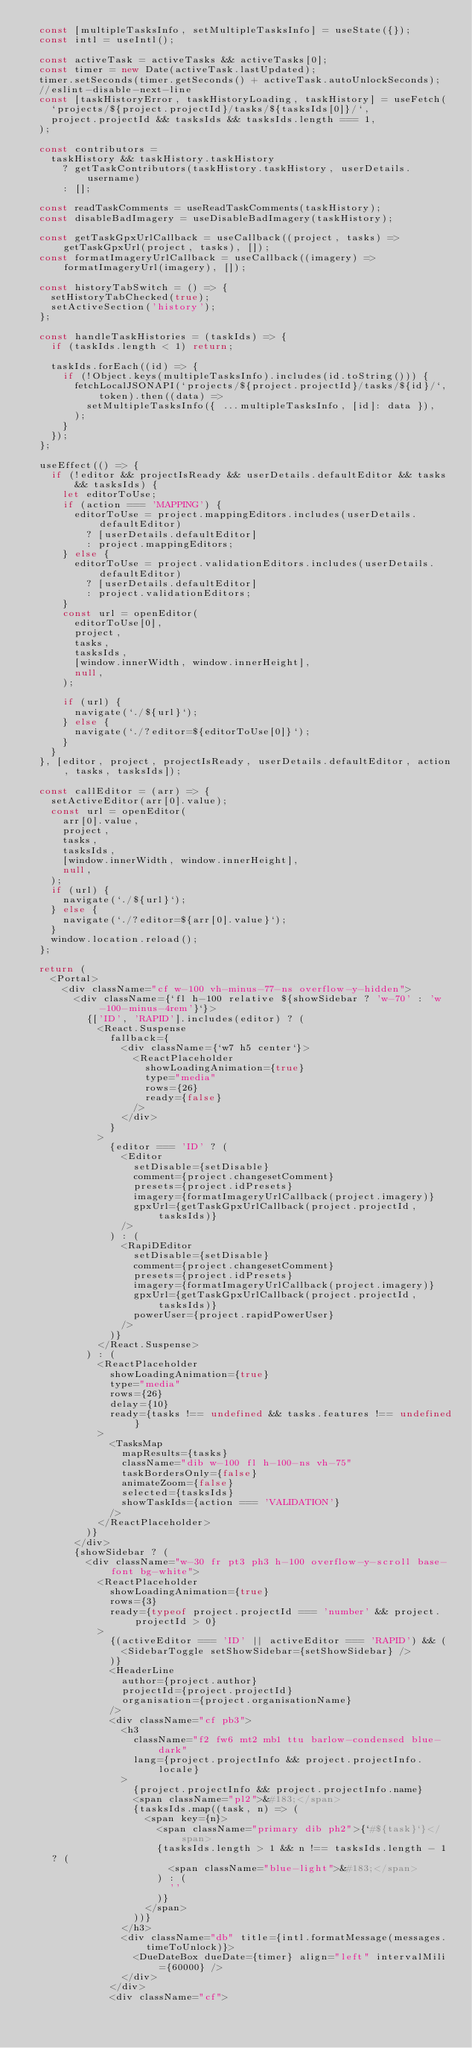Convert code to text. <code><loc_0><loc_0><loc_500><loc_500><_JavaScript_>  const [multipleTasksInfo, setMultipleTasksInfo] = useState({});
  const intl = useIntl();

  const activeTask = activeTasks && activeTasks[0];
  const timer = new Date(activeTask.lastUpdated);
  timer.setSeconds(timer.getSeconds() + activeTask.autoUnlockSeconds);
  //eslint-disable-next-line
  const [taskHistoryError, taskHistoryLoading, taskHistory] = useFetch(
    `projects/${project.projectId}/tasks/${tasksIds[0]}/`,
    project.projectId && tasksIds && tasksIds.length === 1,
  );

  const contributors =
    taskHistory && taskHistory.taskHistory
      ? getTaskContributors(taskHistory.taskHistory, userDetails.username)
      : [];

  const readTaskComments = useReadTaskComments(taskHistory);
  const disableBadImagery = useDisableBadImagery(taskHistory);

  const getTaskGpxUrlCallback = useCallback((project, tasks) => getTaskGpxUrl(project, tasks), []);
  const formatImageryUrlCallback = useCallback((imagery) => formatImageryUrl(imagery), []);

  const historyTabSwitch = () => {
    setHistoryTabChecked(true);
    setActiveSection('history');
  };

  const handleTaskHistories = (taskIds) => {
    if (taskIds.length < 1) return;

    taskIds.forEach((id) => {
      if (!Object.keys(multipleTasksInfo).includes(id.toString())) {
        fetchLocalJSONAPI(`projects/${project.projectId}/tasks/${id}/`, token).then((data) =>
          setMultipleTasksInfo({ ...multipleTasksInfo, [id]: data }),
        );
      }
    });
  };

  useEffect(() => {
    if (!editor && projectIsReady && userDetails.defaultEditor && tasks && tasksIds) {
      let editorToUse;
      if (action === 'MAPPING') {
        editorToUse = project.mappingEditors.includes(userDetails.defaultEditor)
          ? [userDetails.defaultEditor]
          : project.mappingEditors;
      } else {
        editorToUse = project.validationEditors.includes(userDetails.defaultEditor)
          ? [userDetails.defaultEditor]
          : project.validationEditors;
      }
      const url = openEditor(
        editorToUse[0],
        project,
        tasks,
        tasksIds,
        [window.innerWidth, window.innerHeight],
        null,
      );

      if (url) {
        navigate(`./${url}`);
      } else {
        navigate(`./?editor=${editorToUse[0]}`);
      }
    }
  }, [editor, project, projectIsReady, userDetails.defaultEditor, action, tasks, tasksIds]);

  const callEditor = (arr) => {
    setActiveEditor(arr[0].value);
    const url = openEditor(
      arr[0].value,
      project,
      tasks,
      tasksIds,
      [window.innerWidth, window.innerHeight],
      null,
    );
    if (url) {
      navigate(`./${url}`);
    } else {
      navigate(`./?editor=${arr[0].value}`);
    }
    window.location.reload();
  };

  return (
    <Portal>
      <div className="cf w-100 vh-minus-77-ns overflow-y-hidden">
        <div className={`fl h-100 relative ${showSidebar ? 'w-70' : 'w-100-minus-4rem'}`}>
          {['ID', 'RAPID'].includes(editor) ? (
            <React.Suspense
              fallback={
                <div className={`w7 h5 center`}>
                  <ReactPlaceholder
                    showLoadingAnimation={true}
                    type="media"
                    rows={26}
                    ready={false}
                  />
                </div>
              }
            >
              {editor === 'ID' ? (
                <Editor
                  setDisable={setDisable}
                  comment={project.changesetComment}
                  presets={project.idPresets}
                  imagery={formatImageryUrlCallback(project.imagery)}
                  gpxUrl={getTaskGpxUrlCallback(project.projectId, tasksIds)}
                />
              ) : (
                <RapiDEditor
                  setDisable={setDisable}
                  comment={project.changesetComment}
                  presets={project.idPresets}
                  imagery={formatImageryUrlCallback(project.imagery)}
                  gpxUrl={getTaskGpxUrlCallback(project.projectId, tasksIds)}
                  powerUser={project.rapidPowerUser}
                />
              )}
            </React.Suspense>
          ) : (
            <ReactPlaceholder
              showLoadingAnimation={true}
              type="media"
              rows={26}
              delay={10}
              ready={tasks !== undefined && tasks.features !== undefined}
            >
              <TasksMap
                mapResults={tasks}
                className="dib w-100 fl h-100-ns vh-75"
                taskBordersOnly={false}
                animateZoom={false}
                selected={tasksIds}
                showTaskIds={action === 'VALIDATION'}
              />
            </ReactPlaceholder>
          )}
        </div>
        {showSidebar ? (
          <div className="w-30 fr pt3 ph3 h-100 overflow-y-scroll base-font bg-white">
            <ReactPlaceholder
              showLoadingAnimation={true}
              rows={3}
              ready={typeof project.projectId === 'number' && project.projectId > 0}
            >
              {(activeEditor === 'ID' || activeEditor === 'RAPID') && (
                <SidebarToggle setShowSidebar={setShowSidebar} />
              )}
              <HeaderLine
                author={project.author}
                projectId={project.projectId}
                organisation={project.organisationName}
              />
              <div className="cf pb3">
                <h3
                  className="f2 fw6 mt2 mb1 ttu barlow-condensed blue-dark"
                  lang={project.projectInfo && project.projectInfo.locale}
                >
                  {project.projectInfo && project.projectInfo.name}
                  <span className="pl2">&#183;</span>
                  {tasksIds.map((task, n) => (
                    <span key={n}>
                      <span className="primary dib ph2">{`#${task}`}</span>
                      {tasksIds.length > 1 && n !== tasksIds.length - 1 ? (
                        <span className="blue-light">&#183;</span>
                      ) : (
                        ''
                      )}
                    </span>
                  ))}
                </h3>
                <div className="db" title={intl.formatMessage(messages.timeToUnlock)}>
                  <DueDateBox dueDate={timer} align="left" intervalMili={60000} />
                </div>
              </div>
              <div className="cf"></code> 